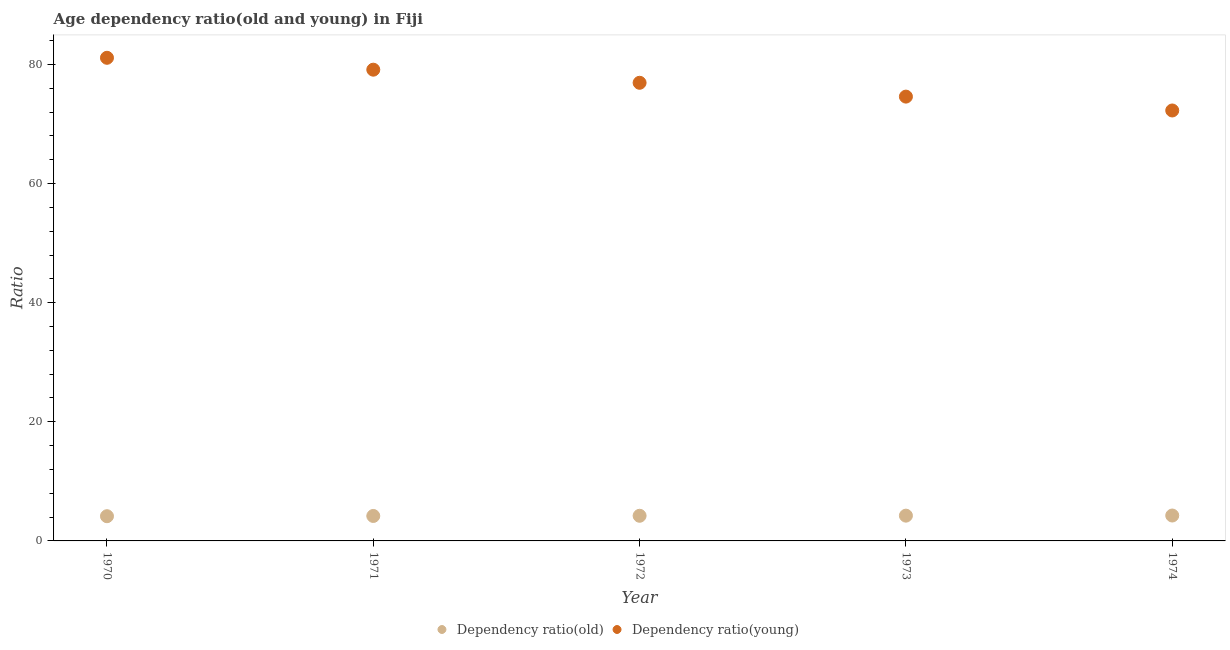How many different coloured dotlines are there?
Your response must be concise. 2. What is the age dependency ratio(young) in 1971?
Offer a very short reply. 79.12. Across all years, what is the maximum age dependency ratio(young)?
Keep it short and to the point. 81.11. Across all years, what is the minimum age dependency ratio(old)?
Make the answer very short. 4.15. In which year was the age dependency ratio(old) maximum?
Provide a succinct answer. 1974. In which year was the age dependency ratio(young) minimum?
Provide a short and direct response. 1974. What is the total age dependency ratio(young) in the graph?
Provide a succinct answer. 384.02. What is the difference between the age dependency ratio(old) in 1972 and that in 1974?
Your response must be concise. -0.04. What is the difference between the age dependency ratio(old) in 1973 and the age dependency ratio(young) in 1970?
Offer a terse response. -76.87. What is the average age dependency ratio(young) per year?
Make the answer very short. 76.8. In the year 1970, what is the difference between the age dependency ratio(old) and age dependency ratio(young)?
Offer a very short reply. -76.96. In how many years, is the age dependency ratio(young) greater than 36?
Your answer should be very brief. 5. What is the ratio of the age dependency ratio(young) in 1970 to that in 1973?
Your answer should be very brief. 1.09. Is the age dependency ratio(young) in 1970 less than that in 1972?
Your answer should be very brief. No. What is the difference between the highest and the second highest age dependency ratio(old)?
Make the answer very short. 0.02. What is the difference between the highest and the lowest age dependency ratio(old)?
Provide a succinct answer. 0.11. In how many years, is the age dependency ratio(young) greater than the average age dependency ratio(young) taken over all years?
Your answer should be compact. 3. Is the sum of the age dependency ratio(old) in 1971 and 1972 greater than the maximum age dependency ratio(young) across all years?
Offer a terse response. No. How many dotlines are there?
Keep it short and to the point. 2. Are the values on the major ticks of Y-axis written in scientific E-notation?
Keep it short and to the point. No. Does the graph contain grids?
Provide a succinct answer. No. What is the title of the graph?
Offer a very short reply. Age dependency ratio(old and young) in Fiji. Does "Taxes on profits and capital gains" appear as one of the legend labels in the graph?
Your response must be concise. No. What is the label or title of the Y-axis?
Keep it short and to the point. Ratio. What is the Ratio in Dependency ratio(old) in 1970?
Make the answer very short. 4.15. What is the Ratio in Dependency ratio(young) in 1970?
Keep it short and to the point. 81.11. What is the Ratio in Dependency ratio(old) in 1971?
Your answer should be very brief. 4.19. What is the Ratio in Dependency ratio(young) in 1971?
Provide a short and direct response. 79.12. What is the Ratio in Dependency ratio(old) in 1972?
Your answer should be very brief. 4.22. What is the Ratio of Dependency ratio(young) in 1972?
Provide a short and direct response. 76.92. What is the Ratio of Dependency ratio(old) in 1973?
Your answer should be very brief. 4.24. What is the Ratio in Dependency ratio(young) in 1973?
Ensure brevity in your answer.  74.6. What is the Ratio in Dependency ratio(old) in 1974?
Ensure brevity in your answer.  4.26. What is the Ratio in Dependency ratio(young) in 1974?
Give a very brief answer. 72.27. Across all years, what is the maximum Ratio in Dependency ratio(old)?
Offer a very short reply. 4.26. Across all years, what is the maximum Ratio in Dependency ratio(young)?
Make the answer very short. 81.11. Across all years, what is the minimum Ratio of Dependency ratio(old)?
Keep it short and to the point. 4.15. Across all years, what is the minimum Ratio of Dependency ratio(young)?
Your answer should be very brief. 72.27. What is the total Ratio in Dependency ratio(old) in the graph?
Provide a succinct answer. 21.07. What is the total Ratio of Dependency ratio(young) in the graph?
Your answer should be very brief. 384.02. What is the difference between the Ratio of Dependency ratio(old) in 1970 and that in 1971?
Keep it short and to the point. -0.04. What is the difference between the Ratio of Dependency ratio(young) in 1970 and that in 1971?
Provide a succinct answer. 2. What is the difference between the Ratio in Dependency ratio(old) in 1970 and that in 1972?
Provide a short and direct response. -0.07. What is the difference between the Ratio of Dependency ratio(young) in 1970 and that in 1972?
Your response must be concise. 4.2. What is the difference between the Ratio of Dependency ratio(old) in 1970 and that in 1973?
Your response must be concise. -0.09. What is the difference between the Ratio of Dependency ratio(young) in 1970 and that in 1973?
Offer a very short reply. 6.52. What is the difference between the Ratio in Dependency ratio(old) in 1970 and that in 1974?
Make the answer very short. -0.11. What is the difference between the Ratio of Dependency ratio(young) in 1970 and that in 1974?
Ensure brevity in your answer.  8.85. What is the difference between the Ratio of Dependency ratio(old) in 1971 and that in 1972?
Provide a short and direct response. -0.03. What is the difference between the Ratio of Dependency ratio(young) in 1971 and that in 1972?
Provide a succinct answer. 2.2. What is the difference between the Ratio in Dependency ratio(old) in 1971 and that in 1973?
Your response must be concise. -0.05. What is the difference between the Ratio of Dependency ratio(young) in 1971 and that in 1973?
Keep it short and to the point. 4.52. What is the difference between the Ratio in Dependency ratio(old) in 1971 and that in 1974?
Give a very brief answer. -0.07. What is the difference between the Ratio in Dependency ratio(young) in 1971 and that in 1974?
Provide a succinct answer. 6.85. What is the difference between the Ratio in Dependency ratio(old) in 1972 and that in 1973?
Make the answer very short. -0.02. What is the difference between the Ratio in Dependency ratio(young) in 1972 and that in 1973?
Give a very brief answer. 2.32. What is the difference between the Ratio of Dependency ratio(old) in 1972 and that in 1974?
Give a very brief answer. -0.04. What is the difference between the Ratio of Dependency ratio(young) in 1972 and that in 1974?
Provide a short and direct response. 4.65. What is the difference between the Ratio of Dependency ratio(old) in 1973 and that in 1974?
Offer a very short reply. -0.02. What is the difference between the Ratio in Dependency ratio(young) in 1973 and that in 1974?
Make the answer very short. 2.33. What is the difference between the Ratio in Dependency ratio(old) in 1970 and the Ratio in Dependency ratio(young) in 1971?
Offer a very short reply. -74.97. What is the difference between the Ratio in Dependency ratio(old) in 1970 and the Ratio in Dependency ratio(young) in 1972?
Your answer should be compact. -72.77. What is the difference between the Ratio of Dependency ratio(old) in 1970 and the Ratio of Dependency ratio(young) in 1973?
Your answer should be very brief. -70.45. What is the difference between the Ratio in Dependency ratio(old) in 1970 and the Ratio in Dependency ratio(young) in 1974?
Your response must be concise. -68.12. What is the difference between the Ratio of Dependency ratio(old) in 1971 and the Ratio of Dependency ratio(young) in 1972?
Make the answer very short. -72.73. What is the difference between the Ratio in Dependency ratio(old) in 1971 and the Ratio in Dependency ratio(young) in 1973?
Give a very brief answer. -70.41. What is the difference between the Ratio in Dependency ratio(old) in 1971 and the Ratio in Dependency ratio(young) in 1974?
Provide a succinct answer. -68.08. What is the difference between the Ratio in Dependency ratio(old) in 1972 and the Ratio in Dependency ratio(young) in 1973?
Your response must be concise. -70.38. What is the difference between the Ratio in Dependency ratio(old) in 1972 and the Ratio in Dependency ratio(young) in 1974?
Give a very brief answer. -68.05. What is the difference between the Ratio in Dependency ratio(old) in 1973 and the Ratio in Dependency ratio(young) in 1974?
Provide a short and direct response. -68.03. What is the average Ratio of Dependency ratio(old) per year?
Provide a succinct answer. 4.21. What is the average Ratio of Dependency ratio(young) per year?
Make the answer very short. 76.8. In the year 1970, what is the difference between the Ratio of Dependency ratio(old) and Ratio of Dependency ratio(young)?
Provide a succinct answer. -76.96. In the year 1971, what is the difference between the Ratio in Dependency ratio(old) and Ratio in Dependency ratio(young)?
Your response must be concise. -74.93. In the year 1972, what is the difference between the Ratio of Dependency ratio(old) and Ratio of Dependency ratio(young)?
Keep it short and to the point. -72.7. In the year 1973, what is the difference between the Ratio in Dependency ratio(old) and Ratio in Dependency ratio(young)?
Ensure brevity in your answer.  -70.35. In the year 1974, what is the difference between the Ratio in Dependency ratio(old) and Ratio in Dependency ratio(young)?
Your answer should be compact. -68. What is the ratio of the Ratio of Dependency ratio(old) in 1970 to that in 1971?
Ensure brevity in your answer.  0.99. What is the ratio of the Ratio of Dependency ratio(young) in 1970 to that in 1971?
Offer a terse response. 1.03. What is the ratio of the Ratio of Dependency ratio(old) in 1970 to that in 1972?
Provide a succinct answer. 0.98. What is the ratio of the Ratio in Dependency ratio(young) in 1970 to that in 1972?
Offer a very short reply. 1.05. What is the ratio of the Ratio in Dependency ratio(young) in 1970 to that in 1973?
Your response must be concise. 1.09. What is the ratio of the Ratio of Dependency ratio(old) in 1970 to that in 1974?
Offer a very short reply. 0.97. What is the ratio of the Ratio of Dependency ratio(young) in 1970 to that in 1974?
Provide a succinct answer. 1.12. What is the ratio of the Ratio in Dependency ratio(young) in 1971 to that in 1972?
Give a very brief answer. 1.03. What is the ratio of the Ratio in Dependency ratio(old) in 1971 to that in 1973?
Your response must be concise. 0.99. What is the ratio of the Ratio of Dependency ratio(young) in 1971 to that in 1973?
Your answer should be very brief. 1.06. What is the ratio of the Ratio in Dependency ratio(old) in 1971 to that in 1974?
Make the answer very short. 0.98. What is the ratio of the Ratio of Dependency ratio(young) in 1971 to that in 1974?
Your answer should be compact. 1.09. What is the ratio of the Ratio in Dependency ratio(old) in 1972 to that in 1973?
Give a very brief answer. 0.99. What is the ratio of the Ratio in Dependency ratio(young) in 1972 to that in 1973?
Provide a short and direct response. 1.03. What is the ratio of the Ratio of Dependency ratio(young) in 1972 to that in 1974?
Provide a short and direct response. 1.06. What is the ratio of the Ratio in Dependency ratio(young) in 1973 to that in 1974?
Give a very brief answer. 1.03. What is the difference between the highest and the second highest Ratio in Dependency ratio(old)?
Provide a succinct answer. 0.02. What is the difference between the highest and the second highest Ratio of Dependency ratio(young)?
Ensure brevity in your answer.  2. What is the difference between the highest and the lowest Ratio of Dependency ratio(old)?
Your answer should be compact. 0.11. What is the difference between the highest and the lowest Ratio of Dependency ratio(young)?
Give a very brief answer. 8.85. 